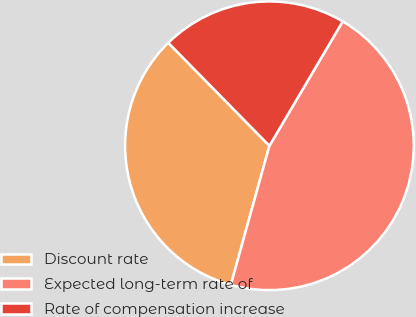Convert chart to OTSL. <chart><loc_0><loc_0><loc_500><loc_500><pie_chart><fcel>Discount rate<fcel>Expected long-term rate of<fcel>Rate of compensation increase<nl><fcel>33.33%<fcel>45.83%<fcel>20.83%<nl></chart> 